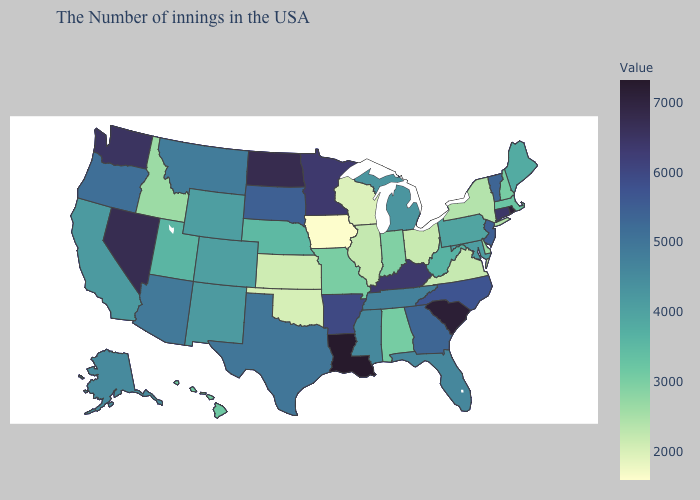Does Massachusetts have the lowest value in the Northeast?
Keep it brief. No. Among the states that border New Jersey , does Delaware have the lowest value?
Write a very short answer. No. Does Arizona have the lowest value in the West?
Be succinct. No. Does Alabama have a lower value than Virginia?
Short answer required. No. Among the states that border Rhode Island , does Massachusetts have the highest value?
Quick response, please. No. Among the states that border West Virginia , which have the lowest value?
Be succinct. Ohio. Among the states that border Idaho , which have the lowest value?
Give a very brief answer. Utah. Does Iowa have the lowest value in the USA?
Quick response, please. Yes. 